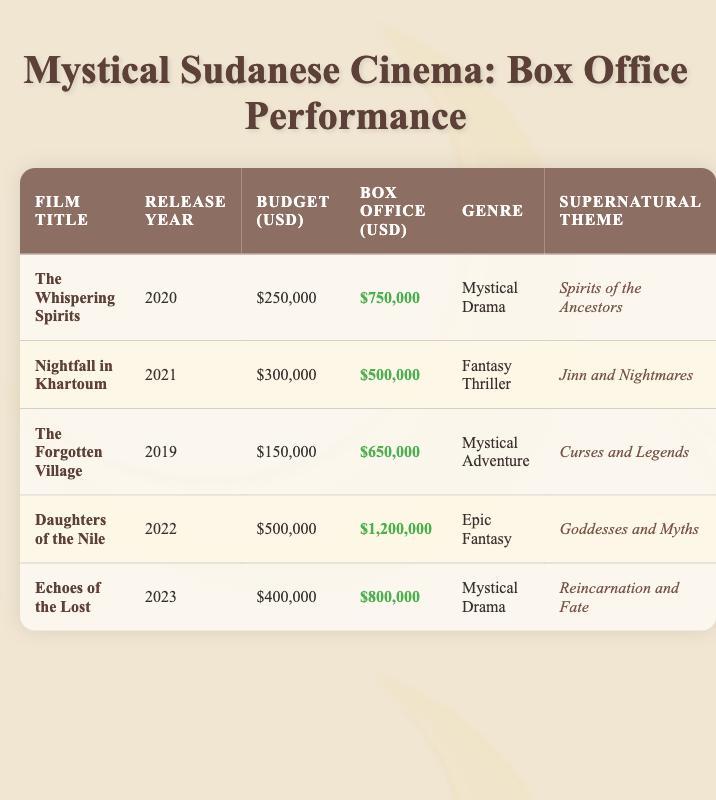What is the box office earnings for "Daughters of the Nile"? The table shows that the box office earnings listed under the "Box Office (USD)" column for "Daughters of the Nile" is $1,200,000.
Answer: $1,200,000 Which film has the highest budget? From the "Budget (USD)" column, "Daughters of the Nile" has the highest budget of $500,000, compared to others which are lower.
Answer: $500,000 What is the total box office revenue of all the films listed? To find the total box office revenue, we sum the box office earnings: 750,000 + 500,000 + 650,000 + 1,200,000 + 800,000 = 3,900,000.
Answer: $3,900,000 Which film released in 2021 has a supernatural theme of "Jinn and Nightmares"? By checking the table, "Nightfall in Khartoum," which was released in 2021, is matched to the supernatural theme of "Jinn and Nightmares."
Answer: Nightfall in Khartoum Is "The Forgotten Village" categorized as an Epic Fantasy? According to the genre column, "The Forgotten Village" is categorized as a "Mystical Adventure," not an "Epic Fantasy," making this statement false.
Answer: No What was the average budget of the films released after 2020? The films released after 2020 are "Daughters of the Nile" ($500,000), "Echoes of the Lost" ($400,000), and "Nightfall in Khartoum" ($300,000). Total budget is 500,000 + 400,000 + 300,000 = 1,200,000, and the average budget across 3 films is 1,200,000 / 3 = 400,000.
Answer: $400,000 How many films have the supernatural theme of "Spirits of the Ancestors"? By reviewing the table, only "The Whispering Spirits" matches this theme, noted in the "Supernatural Theme" column.
Answer: 1 What is the difference in box office earnings between "The Whispering Spirits" and "Nightfall in Khartoum"? The earnings for "The Whispering Spirits" is $750,000 and "Nightfall in Khartoum" is $500,000. The difference is 750,000 - 500,000 = 250,000.
Answer: $250,000 